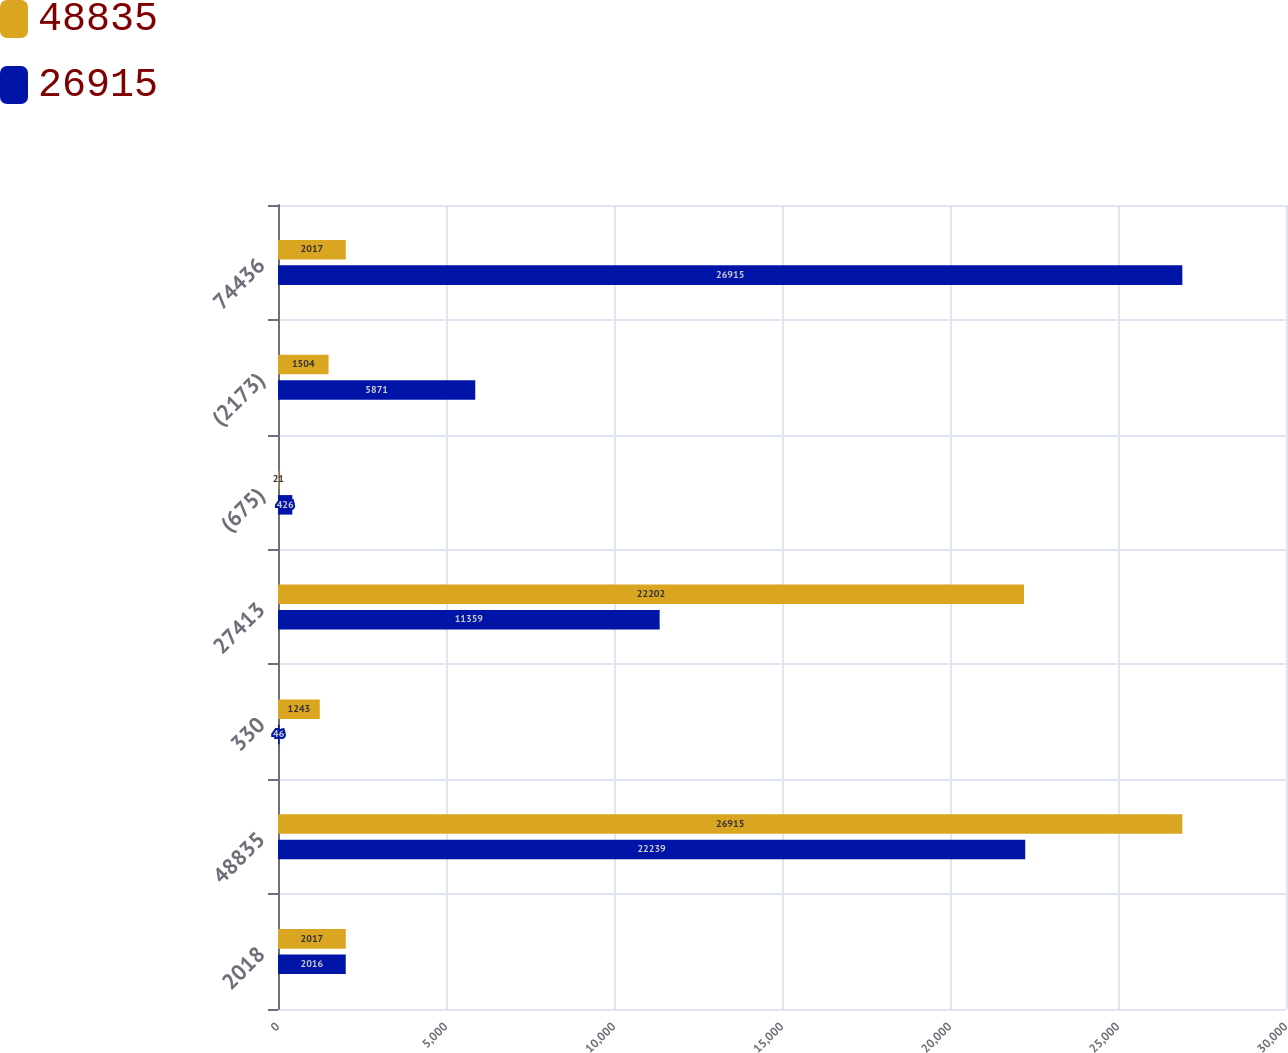Convert chart. <chart><loc_0><loc_0><loc_500><loc_500><stacked_bar_chart><ecel><fcel>2018<fcel>48835<fcel>330<fcel>27413<fcel>(675)<fcel>(2173)<fcel>74436<nl><fcel>48835<fcel>2017<fcel>26915<fcel>1243<fcel>22202<fcel>21<fcel>1504<fcel>2017<nl><fcel>26915<fcel>2016<fcel>22239<fcel>46<fcel>11359<fcel>426<fcel>5871<fcel>26915<nl></chart> 